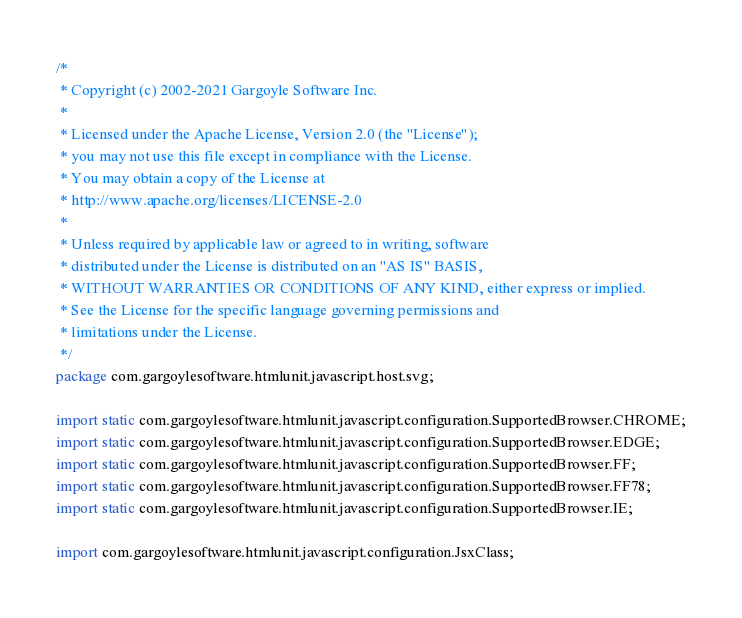<code> <loc_0><loc_0><loc_500><loc_500><_Java_>/*
 * Copyright (c) 2002-2021 Gargoyle Software Inc.
 *
 * Licensed under the Apache License, Version 2.0 (the "License");
 * you may not use this file except in compliance with the License.
 * You may obtain a copy of the License at
 * http://www.apache.org/licenses/LICENSE-2.0
 *
 * Unless required by applicable law or agreed to in writing, software
 * distributed under the License is distributed on an "AS IS" BASIS,
 * WITHOUT WARRANTIES OR CONDITIONS OF ANY KIND, either express or implied.
 * See the License for the specific language governing permissions and
 * limitations under the License.
 */
package com.gargoylesoftware.htmlunit.javascript.host.svg;

import static com.gargoylesoftware.htmlunit.javascript.configuration.SupportedBrowser.CHROME;
import static com.gargoylesoftware.htmlunit.javascript.configuration.SupportedBrowser.EDGE;
import static com.gargoylesoftware.htmlunit.javascript.configuration.SupportedBrowser.FF;
import static com.gargoylesoftware.htmlunit.javascript.configuration.SupportedBrowser.FF78;
import static com.gargoylesoftware.htmlunit.javascript.configuration.SupportedBrowser.IE;

import com.gargoylesoftware.htmlunit.javascript.configuration.JsxClass;</code> 